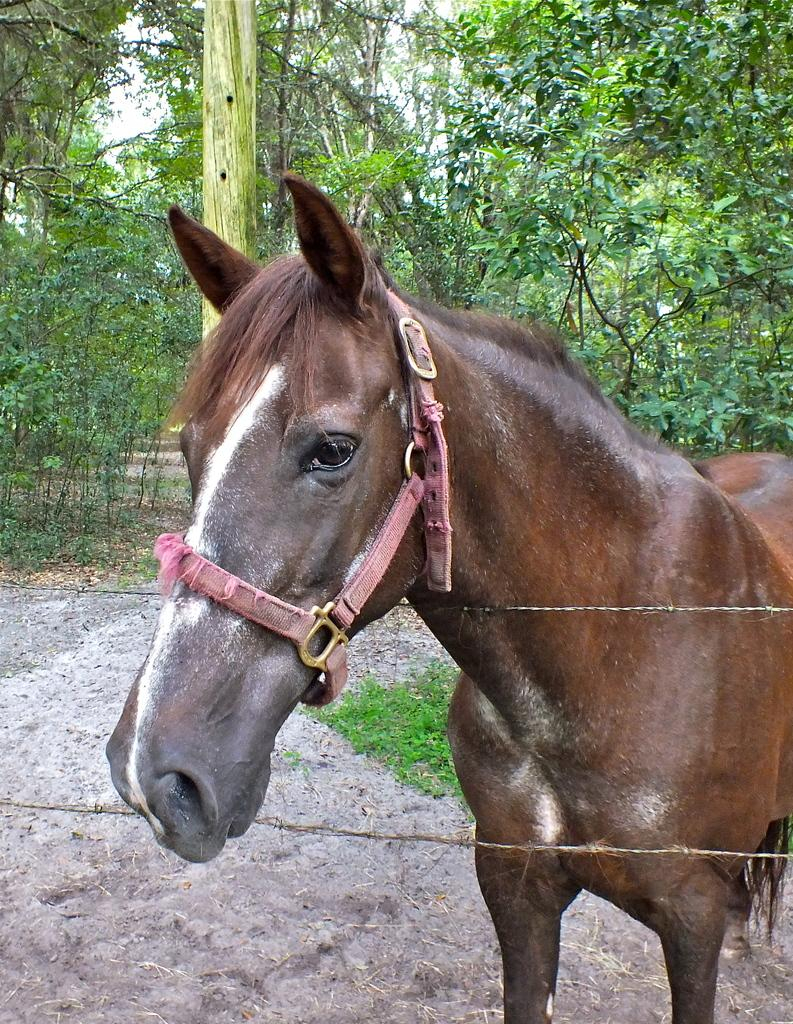What animal can be seen in the image? There is a horse in the image. What is the horse's proximity to a fence? The horse is near a wire fence. What type of vegetation is visible in the background of the image? There is grass visible in the background of the image. What other structures can be seen in the background of the image? There is a wooden pole in the background of the image. What type of natural elements are present in the background of the image? There are trees in the background of the image. What type of vegetable is being harvested by the horse in the image? There is no vegetable being harvested by the horse in the image; the horse is simply near a wire fence. What type of war is depicted in the image? There is no war depicted in the image; it features a horse near a fence with grass, a wooden pole, and trees in the background. 